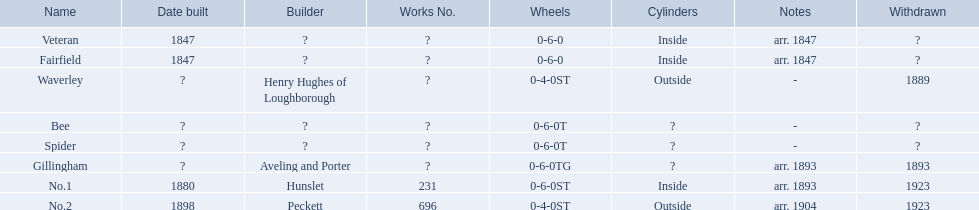Can you describe the aldernay railways? Veteran, Fairfield, Waverley, Bee, Spider, Gillingham, No.1, No.2. Which of these were established in 1847? Veteran, Fairfield. Excluding fairfield, which one is part of this group? Veteran. 